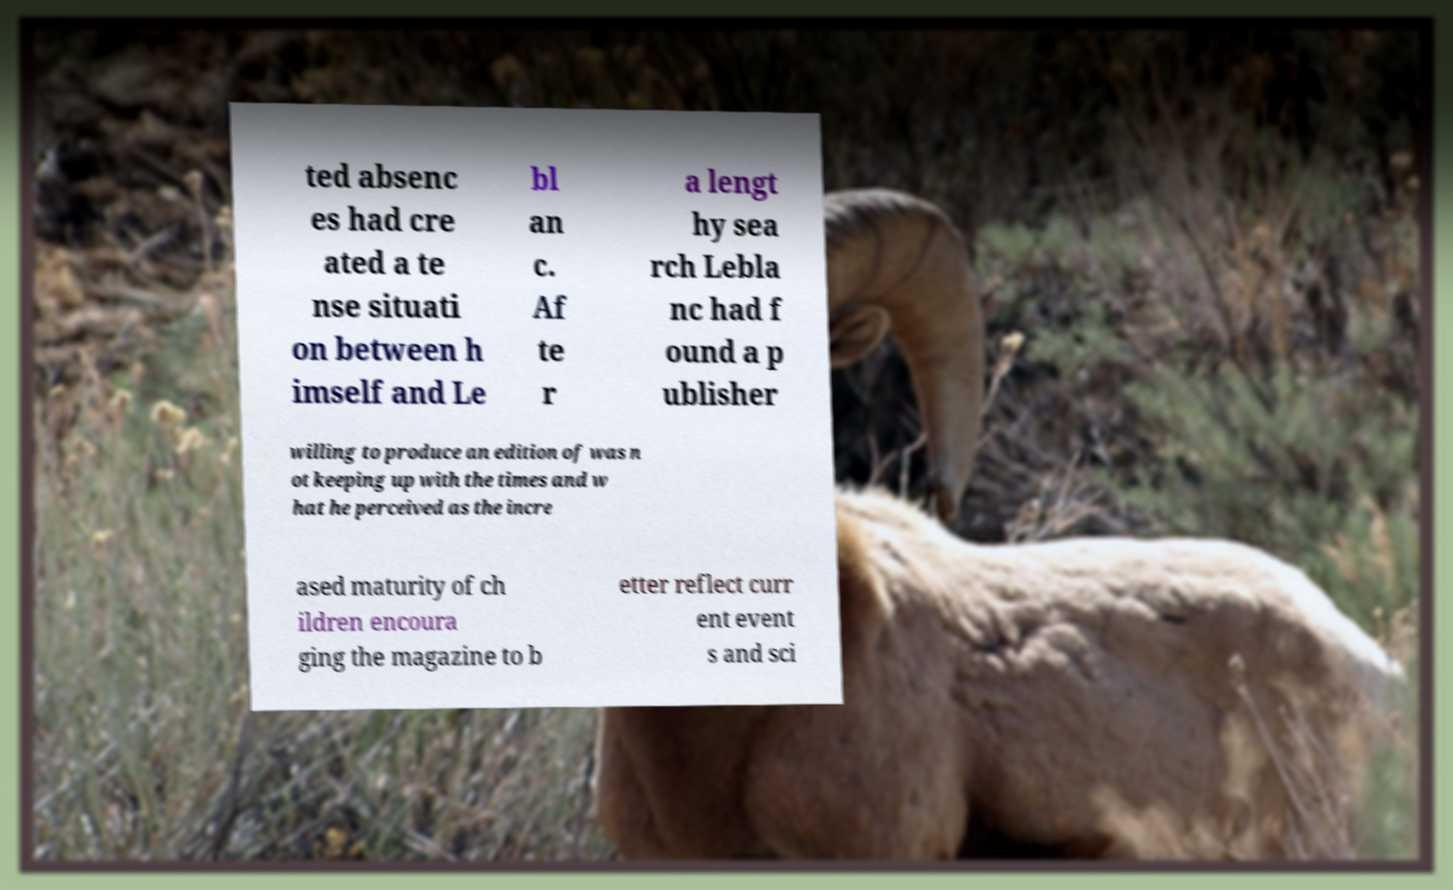Could you extract and type out the text from this image? ted absenc es had cre ated a te nse situati on between h imself and Le bl an c. Af te r a lengt hy sea rch Lebla nc had f ound a p ublisher willing to produce an edition of was n ot keeping up with the times and w hat he perceived as the incre ased maturity of ch ildren encoura ging the magazine to b etter reflect curr ent event s and sci 